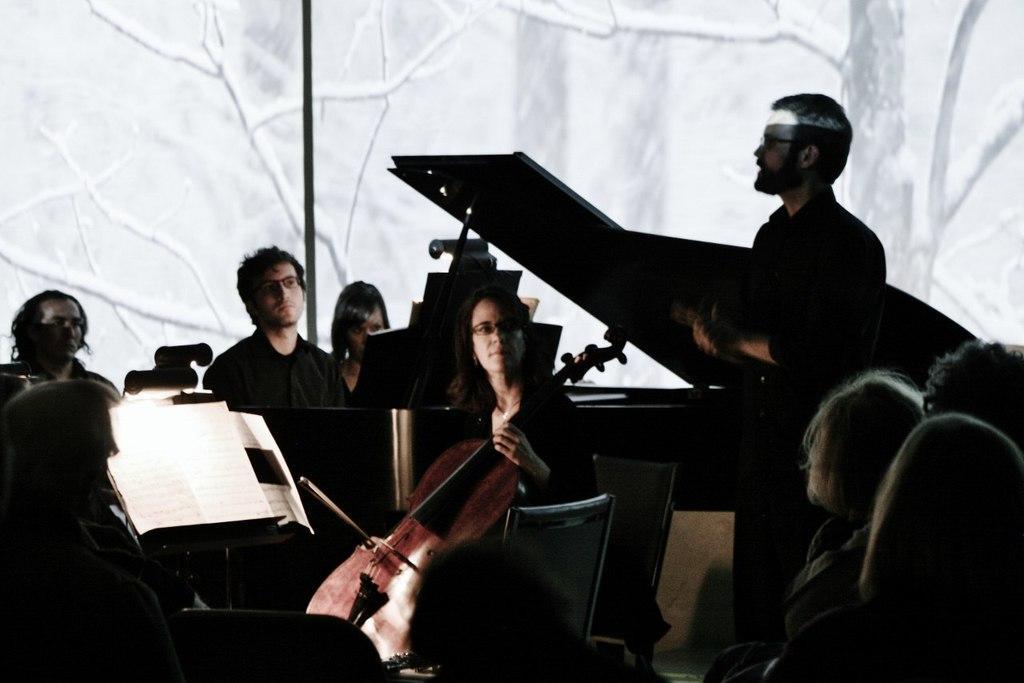In one or two sentences, can you explain what this image depicts? These are bunch of musicians. The woman sitting over here playing a violin. This man is guiding them ,group of people looking at them. The background is nice canvas poster. There is a pole over here. 